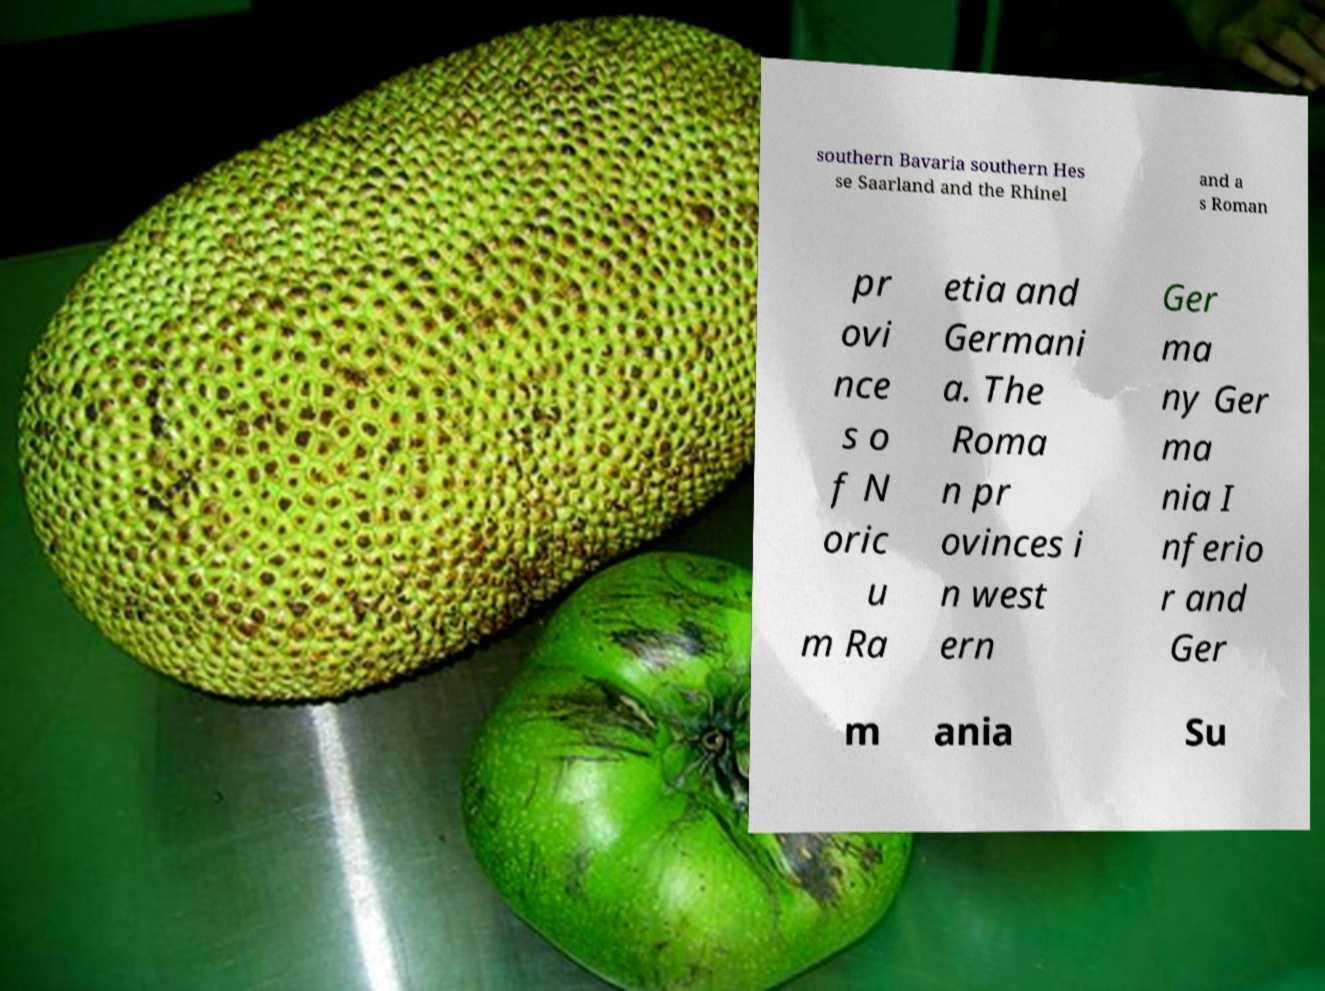I need the written content from this picture converted into text. Can you do that? southern Bavaria southern Hes se Saarland and the Rhinel and a s Roman pr ovi nce s o f N oric u m Ra etia and Germani a. The Roma n pr ovinces i n west ern Ger ma ny Ger ma nia I nferio r and Ger m ania Su 